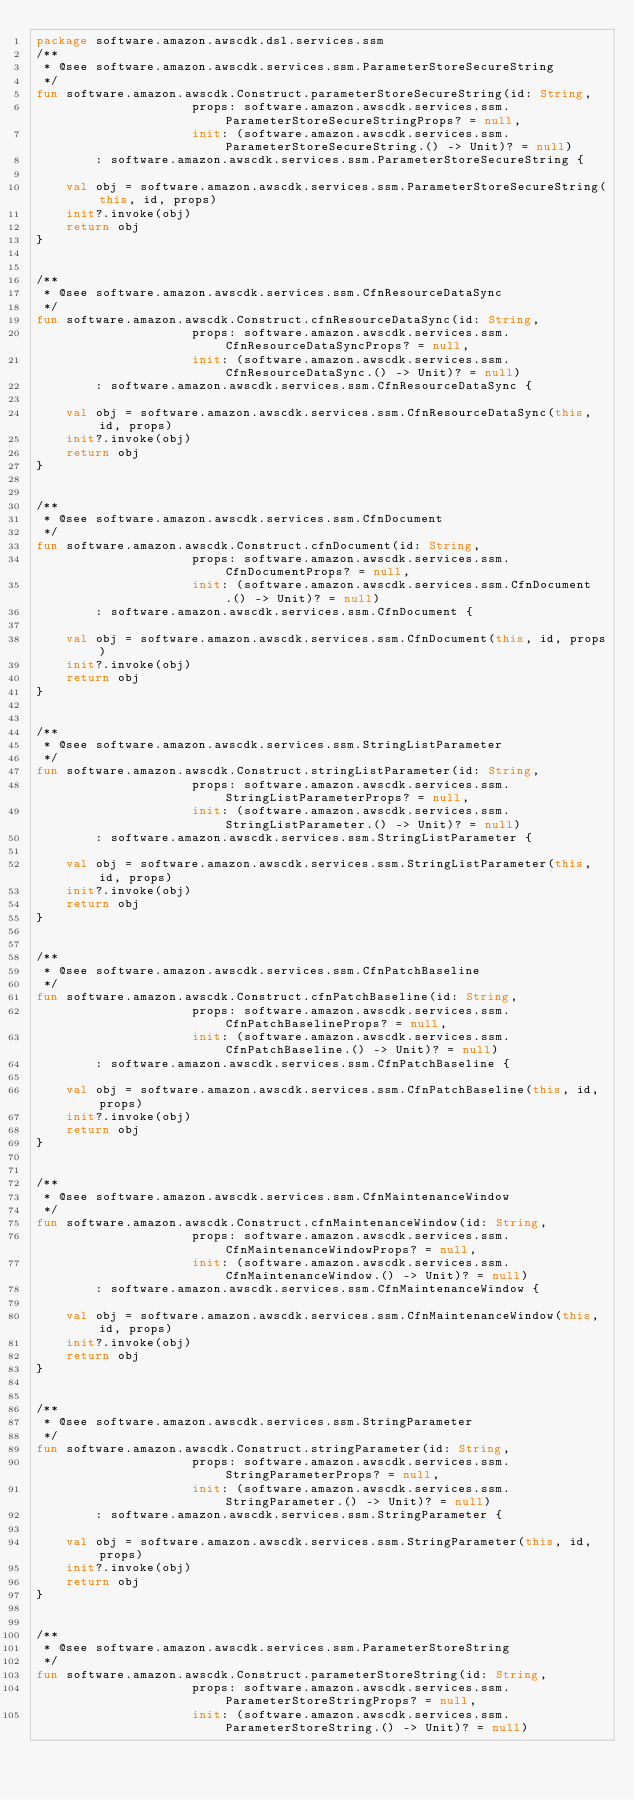<code> <loc_0><loc_0><loc_500><loc_500><_Kotlin_>package software.amazon.awscdk.dsl.services.ssm
/**
 * @see software.amazon.awscdk.services.ssm.ParameterStoreSecureString
 */
fun software.amazon.awscdk.Construct.parameterStoreSecureString(id: String,
                     props: software.amazon.awscdk.services.ssm.ParameterStoreSecureStringProps? = null,
                     init: (software.amazon.awscdk.services.ssm.ParameterStoreSecureString.() -> Unit)? = null)
        : software.amazon.awscdk.services.ssm.ParameterStoreSecureString {

    val obj = software.amazon.awscdk.services.ssm.ParameterStoreSecureString(this, id, props)
    init?.invoke(obj)
    return obj
}


/**
 * @see software.amazon.awscdk.services.ssm.CfnResourceDataSync
 */
fun software.amazon.awscdk.Construct.cfnResourceDataSync(id: String,
                     props: software.amazon.awscdk.services.ssm.CfnResourceDataSyncProps? = null,
                     init: (software.amazon.awscdk.services.ssm.CfnResourceDataSync.() -> Unit)? = null)
        : software.amazon.awscdk.services.ssm.CfnResourceDataSync {

    val obj = software.amazon.awscdk.services.ssm.CfnResourceDataSync(this, id, props)
    init?.invoke(obj)
    return obj
}


/**
 * @see software.amazon.awscdk.services.ssm.CfnDocument
 */
fun software.amazon.awscdk.Construct.cfnDocument(id: String,
                     props: software.amazon.awscdk.services.ssm.CfnDocumentProps? = null,
                     init: (software.amazon.awscdk.services.ssm.CfnDocument.() -> Unit)? = null)
        : software.amazon.awscdk.services.ssm.CfnDocument {

    val obj = software.amazon.awscdk.services.ssm.CfnDocument(this, id, props)
    init?.invoke(obj)
    return obj
}


/**
 * @see software.amazon.awscdk.services.ssm.StringListParameter
 */
fun software.amazon.awscdk.Construct.stringListParameter(id: String,
                     props: software.amazon.awscdk.services.ssm.StringListParameterProps? = null,
                     init: (software.amazon.awscdk.services.ssm.StringListParameter.() -> Unit)? = null)
        : software.amazon.awscdk.services.ssm.StringListParameter {

    val obj = software.amazon.awscdk.services.ssm.StringListParameter(this, id, props)
    init?.invoke(obj)
    return obj
}


/**
 * @see software.amazon.awscdk.services.ssm.CfnPatchBaseline
 */
fun software.amazon.awscdk.Construct.cfnPatchBaseline(id: String,
                     props: software.amazon.awscdk.services.ssm.CfnPatchBaselineProps? = null,
                     init: (software.amazon.awscdk.services.ssm.CfnPatchBaseline.() -> Unit)? = null)
        : software.amazon.awscdk.services.ssm.CfnPatchBaseline {

    val obj = software.amazon.awscdk.services.ssm.CfnPatchBaseline(this, id, props)
    init?.invoke(obj)
    return obj
}


/**
 * @see software.amazon.awscdk.services.ssm.CfnMaintenanceWindow
 */
fun software.amazon.awscdk.Construct.cfnMaintenanceWindow(id: String,
                     props: software.amazon.awscdk.services.ssm.CfnMaintenanceWindowProps? = null,
                     init: (software.amazon.awscdk.services.ssm.CfnMaintenanceWindow.() -> Unit)? = null)
        : software.amazon.awscdk.services.ssm.CfnMaintenanceWindow {

    val obj = software.amazon.awscdk.services.ssm.CfnMaintenanceWindow(this, id, props)
    init?.invoke(obj)
    return obj
}


/**
 * @see software.amazon.awscdk.services.ssm.StringParameter
 */
fun software.amazon.awscdk.Construct.stringParameter(id: String,
                     props: software.amazon.awscdk.services.ssm.StringParameterProps? = null,
                     init: (software.amazon.awscdk.services.ssm.StringParameter.() -> Unit)? = null)
        : software.amazon.awscdk.services.ssm.StringParameter {

    val obj = software.amazon.awscdk.services.ssm.StringParameter(this, id, props)
    init?.invoke(obj)
    return obj
}


/**
 * @see software.amazon.awscdk.services.ssm.ParameterStoreString
 */
fun software.amazon.awscdk.Construct.parameterStoreString(id: String,
                     props: software.amazon.awscdk.services.ssm.ParameterStoreStringProps? = null,
                     init: (software.amazon.awscdk.services.ssm.ParameterStoreString.() -> Unit)? = null)</code> 